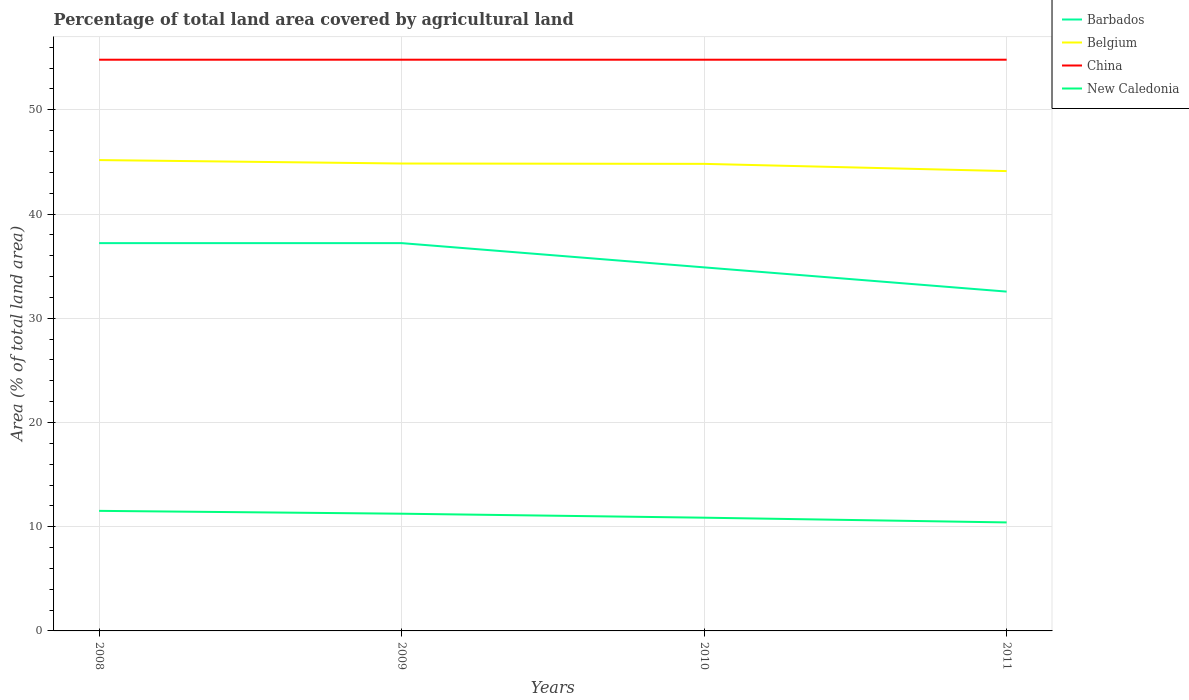How many different coloured lines are there?
Your answer should be very brief. 4. Does the line corresponding to Barbados intersect with the line corresponding to New Caledonia?
Keep it short and to the point. No. Across all years, what is the maximum percentage of agricultural land in Barbados?
Offer a terse response. 32.56. In which year was the percentage of agricultural land in Belgium maximum?
Provide a short and direct response. 2011. What is the total percentage of agricultural land in Belgium in the graph?
Your response must be concise. 0.69. What is the difference between the highest and the second highest percentage of agricultural land in New Caledonia?
Keep it short and to the point. 1.11. What is the difference between the highest and the lowest percentage of agricultural land in Barbados?
Offer a very short reply. 2. Does the graph contain any zero values?
Give a very brief answer. No. Where does the legend appear in the graph?
Provide a succinct answer. Top right. How many legend labels are there?
Your answer should be compact. 4. What is the title of the graph?
Provide a short and direct response. Percentage of total land area covered by agricultural land. Does "World" appear as one of the legend labels in the graph?
Your response must be concise. No. What is the label or title of the Y-axis?
Offer a terse response. Area (% of total land area). What is the Area (% of total land area) in Barbados in 2008?
Keep it short and to the point. 37.21. What is the Area (% of total land area) in Belgium in 2008?
Your response must be concise. 45.18. What is the Area (% of total land area) of China in 2008?
Your answer should be compact. 54.81. What is the Area (% of total land area) in New Caledonia in 2008?
Keep it short and to the point. 11.52. What is the Area (% of total land area) in Barbados in 2009?
Keep it short and to the point. 37.21. What is the Area (% of total land area) of Belgium in 2009?
Your answer should be compact. 44.85. What is the Area (% of total land area) in China in 2009?
Ensure brevity in your answer.  54.81. What is the Area (% of total land area) in New Caledonia in 2009?
Your response must be concise. 11.25. What is the Area (% of total land area) in Barbados in 2010?
Keep it short and to the point. 34.88. What is the Area (% of total land area) in Belgium in 2010?
Make the answer very short. 44.82. What is the Area (% of total land area) in China in 2010?
Offer a very short reply. 54.81. What is the Area (% of total land area) of New Caledonia in 2010?
Make the answer very short. 10.86. What is the Area (% of total land area) of Barbados in 2011?
Ensure brevity in your answer.  32.56. What is the Area (% of total land area) of Belgium in 2011?
Provide a short and direct response. 44.12. What is the Area (% of total land area) in China in 2011?
Offer a terse response. 54.81. What is the Area (% of total land area) in New Caledonia in 2011?
Offer a terse response. 10.41. Across all years, what is the maximum Area (% of total land area) in Barbados?
Provide a short and direct response. 37.21. Across all years, what is the maximum Area (% of total land area) in Belgium?
Give a very brief answer. 45.18. Across all years, what is the maximum Area (% of total land area) in China?
Ensure brevity in your answer.  54.81. Across all years, what is the maximum Area (% of total land area) of New Caledonia?
Give a very brief answer. 11.52. Across all years, what is the minimum Area (% of total land area) of Barbados?
Offer a terse response. 32.56. Across all years, what is the minimum Area (% of total land area) of Belgium?
Your answer should be compact. 44.12. Across all years, what is the minimum Area (% of total land area) in China?
Provide a short and direct response. 54.81. Across all years, what is the minimum Area (% of total land area) of New Caledonia?
Give a very brief answer. 10.41. What is the total Area (% of total land area) of Barbados in the graph?
Your response must be concise. 141.86. What is the total Area (% of total land area) in Belgium in the graph?
Offer a very short reply. 178.96. What is the total Area (% of total land area) of China in the graph?
Keep it short and to the point. 219.23. What is the total Area (% of total land area) in New Caledonia in the graph?
Ensure brevity in your answer.  44.04. What is the difference between the Area (% of total land area) of Barbados in 2008 and that in 2009?
Your answer should be very brief. 0. What is the difference between the Area (% of total land area) in Belgium in 2008 and that in 2009?
Provide a short and direct response. 0.33. What is the difference between the Area (% of total land area) of China in 2008 and that in 2009?
Your response must be concise. -0. What is the difference between the Area (% of total land area) in New Caledonia in 2008 and that in 2009?
Provide a short and direct response. 0.27. What is the difference between the Area (% of total land area) in Barbados in 2008 and that in 2010?
Make the answer very short. 2.33. What is the difference between the Area (% of total land area) of Belgium in 2008 and that in 2010?
Your response must be concise. 0.36. What is the difference between the Area (% of total land area) of China in 2008 and that in 2010?
Your answer should be very brief. -0. What is the difference between the Area (% of total land area) of New Caledonia in 2008 and that in 2010?
Offer a very short reply. 0.66. What is the difference between the Area (% of total land area) in Barbados in 2008 and that in 2011?
Provide a succinct answer. 4.65. What is the difference between the Area (% of total land area) in Belgium in 2008 and that in 2011?
Make the answer very short. 1.06. What is the difference between the Area (% of total land area) in China in 2008 and that in 2011?
Offer a very short reply. -0. What is the difference between the Area (% of total land area) in New Caledonia in 2008 and that in 2011?
Offer a terse response. 1.11. What is the difference between the Area (% of total land area) in Barbados in 2009 and that in 2010?
Provide a succinct answer. 2.33. What is the difference between the Area (% of total land area) in Belgium in 2009 and that in 2010?
Give a very brief answer. 0.03. What is the difference between the Area (% of total land area) of China in 2009 and that in 2010?
Keep it short and to the point. 0. What is the difference between the Area (% of total land area) in New Caledonia in 2009 and that in 2010?
Offer a very short reply. 0.38. What is the difference between the Area (% of total land area) of Barbados in 2009 and that in 2011?
Your answer should be compact. 4.65. What is the difference between the Area (% of total land area) in Belgium in 2009 and that in 2011?
Your response must be concise. 0.73. What is the difference between the Area (% of total land area) of New Caledonia in 2009 and that in 2011?
Give a very brief answer. 0.84. What is the difference between the Area (% of total land area) in Barbados in 2010 and that in 2011?
Provide a short and direct response. 2.33. What is the difference between the Area (% of total land area) in Belgium in 2010 and that in 2011?
Make the answer very short. 0.69. What is the difference between the Area (% of total land area) in China in 2010 and that in 2011?
Provide a short and direct response. -0. What is the difference between the Area (% of total land area) of New Caledonia in 2010 and that in 2011?
Make the answer very short. 0.45. What is the difference between the Area (% of total land area) in Barbados in 2008 and the Area (% of total land area) in Belgium in 2009?
Your answer should be compact. -7.64. What is the difference between the Area (% of total land area) of Barbados in 2008 and the Area (% of total land area) of China in 2009?
Provide a succinct answer. -17.6. What is the difference between the Area (% of total land area) in Barbados in 2008 and the Area (% of total land area) in New Caledonia in 2009?
Your response must be concise. 25.96. What is the difference between the Area (% of total land area) of Belgium in 2008 and the Area (% of total land area) of China in 2009?
Offer a very short reply. -9.63. What is the difference between the Area (% of total land area) in Belgium in 2008 and the Area (% of total land area) in New Caledonia in 2009?
Keep it short and to the point. 33.93. What is the difference between the Area (% of total land area) of China in 2008 and the Area (% of total land area) of New Caledonia in 2009?
Your response must be concise. 43.56. What is the difference between the Area (% of total land area) of Barbados in 2008 and the Area (% of total land area) of Belgium in 2010?
Provide a short and direct response. -7.61. What is the difference between the Area (% of total land area) of Barbados in 2008 and the Area (% of total land area) of China in 2010?
Your response must be concise. -17.6. What is the difference between the Area (% of total land area) of Barbados in 2008 and the Area (% of total land area) of New Caledonia in 2010?
Your answer should be compact. 26.34. What is the difference between the Area (% of total land area) of Belgium in 2008 and the Area (% of total land area) of China in 2010?
Offer a very short reply. -9.63. What is the difference between the Area (% of total land area) of Belgium in 2008 and the Area (% of total land area) of New Caledonia in 2010?
Your answer should be very brief. 34.31. What is the difference between the Area (% of total land area) of China in 2008 and the Area (% of total land area) of New Caledonia in 2010?
Provide a succinct answer. 43.94. What is the difference between the Area (% of total land area) of Barbados in 2008 and the Area (% of total land area) of Belgium in 2011?
Your response must be concise. -6.91. What is the difference between the Area (% of total land area) of Barbados in 2008 and the Area (% of total land area) of China in 2011?
Your answer should be compact. -17.6. What is the difference between the Area (% of total land area) in Barbados in 2008 and the Area (% of total land area) in New Caledonia in 2011?
Ensure brevity in your answer.  26.8. What is the difference between the Area (% of total land area) in Belgium in 2008 and the Area (% of total land area) in China in 2011?
Provide a short and direct response. -9.63. What is the difference between the Area (% of total land area) of Belgium in 2008 and the Area (% of total land area) of New Caledonia in 2011?
Your response must be concise. 34.77. What is the difference between the Area (% of total land area) of China in 2008 and the Area (% of total land area) of New Caledonia in 2011?
Keep it short and to the point. 44.4. What is the difference between the Area (% of total land area) in Barbados in 2009 and the Area (% of total land area) in Belgium in 2010?
Make the answer very short. -7.61. What is the difference between the Area (% of total land area) in Barbados in 2009 and the Area (% of total land area) in China in 2010?
Make the answer very short. -17.6. What is the difference between the Area (% of total land area) of Barbados in 2009 and the Area (% of total land area) of New Caledonia in 2010?
Give a very brief answer. 26.34. What is the difference between the Area (% of total land area) of Belgium in 2009 and the Area (% of total land area) of China in 2010?
Give a very brief answer. -9.96. What is the difference between the Area (% of total land area) in Belgium in 2009 and the Area (% of total land area) in New Caledonia in 2010?
Your response must be concise. 33.98. What is the difference between the Area (% of total land area) of China in 2009 and the Area (% of total land area) of New Caledonia in 2010?
Ensure brevity in your answer.  43.94. What is the difference between the Area (% of total land area) of Barbados in 2009 and the Area (% of total land area) of Belgium in 2011?
Your response must be concise. -6.91. What is the difference between the Area (% of total land area) in Barbados in 2009 and the Area (% of total land area) in China in 2011?
Keep it short and to the point. -17.6. What is the difference between the Area (% of total land area) of Barbados in 2009 and the Area (% of total land area) of New Caledonia in 2011?
Keep it short and to the point. 26.8. What is the difference between the Area (% of total land area) of Belgium in 2009 and the Area (% of total land area) of China in 2011?
Offer a terse response. -9.96. What is the difference between the Area (% of total land area) in Belgium in 2009 and the Area (% of total land area) in New Caledonia in 2011?
Your response must be concise. 34.44. What is the difference between the Area (% of total land area) in China in 2009 and the Area (% of total land area) in New Caledonia in 2011?
Give a very brief answer. 44.4. What is the difference between the Area (% of total land area) of Barbados in 2010 and the Area (% of total land area) of Belgium in 2011?
Offer a terse response. -9.24. What is the difference between the Area (% of total land area) of Barbados in 2010 and the Area (% of total land area) of China in 2011?
Your answer should be compact. -19.92. What is the difference between the Area (% of total land area) in Barbados in 2010 and the Area (% of total land area) in New Caledonia in 2011?
Offer a very short reply. 24.47. What is the difference between the Area (% of total land area) of Belgium in 2010 and the Area (% of total land area) of China in 2011?
Offer a very short reply. -9.99. What is the difference between the Area (% of total land area) of Belgium in 2010 and the Area (% of total land area) of New Caledonia in 2011?
Offer a terse response. 34.4. What is the difference between the Area (% of total land area) in China in 2010 and the Area (% of total land area) in New Caledonia in 2011?
Your response must be concise. 44.4. What is the average Area (% of total land area) of Barbados per year?
Offer a very short reply. 35.47. What is the average Area (% of total land area) of Belgium per year?
Offer a very short reply. 44.74. What is the average Area (% of total land area) in China per year?
Give a very brief answer. 54.81. What is the average Area (% of total land area) in New Caledonia per year?
Your answer should be compact. 11.01. In the year 2008, what is the difference between the Area (% of total land area) in Barbados and Area (% of total land area) in Belgium?
Give a very brief answer. -7.97. In the year 2008, what is the difference between the Area (% of total land area) in Barbados and Area (% of total land area) in China?
Give a very brief answer. -17.6. In the year 2008, what is the difference between the Area (% of total land area) in Barbados and Area (% of total land area) in New Caledonia?
Keep it short and to the point. 25.69. In the year 2008, what is the difference between the Area (% of total land area) of Belgium and Area (% of total land area) of China?
Keep it short and to the point. -9.63. In the year 2008, what is the difference between the Area (% of total land area) of Belgium and Area (% of total land area) of New Caledonia?
Give a very brief answer. 33.66. In the year 2008, what is the difference between the Area (% of total land area) of China and Area (% of total land area) of New Caledonia?
Give a very brief answer. 43.29. In the year 2009, what is the difference between the Area (% of total land area) in Barbados and Area (% of total land area) in Belgium?
Ensure brevity in your answer.  -7.64. In the year 2009, what is the difference between the Area (% of total land area) of Barbados and Area (% of total land area) of China?
Ensure brevity in your answer.  -17.6. In the year 2009, what is the difference between the Area (% of total land area) in Barbados and Area (% of total land area) in New Caledonia?
Provide a succinct answer. 25.96. In the year 2009, what is the difference between the Area (% of total land area) in Belgium and Area (% of total land area) in China?
Your answer should be compact. -9.96. In the year 2009, what is the difference between the Area (% of total land area) in Belgium and Area (% of total land area) in New Caledonia?
Keep it short and to the point. 33.6. In the year 2009, what is the difference between the Area (% of total land area) of China and Area (% of total land area) of New Caledonia?
Your answer should be compact. 43.56. In the year 2010, what is the difference between the Area (% of total land area) in Barbados and Area (% of total land area) in Belgium?
Your response must be concise. -9.93. In the year 2010, what is the difference between the Area (% of total land area) in Barbados and Area (% of total land area) in China?
Offer a very short reply. -19.92. In the year 2010, what is the difference between the Area (% of total land area) in Barbados and Area (% of total land area) in New Caledonia?
Provide a short and direct response. 24.02. In the year 2010, what is the difference between the Area (% of total land area) of Belgium and Area (% of total land area) of China?
Ensure brevity in your answer.  -9.99. In the year 2010, what is the difference between the Area (% of total land area) of Belgium and Area (% of total land area) of New Caledonia?
Give a very brief answer. 33.95. In the year 2010, what is the difference between the Area (% of total land area) of China and Area (% of total land area) of New Caledonia?
Keep it short and to the point. 43.94. In the year 2011, what is the difference between the Area (% of total land area) of Barbados and Area (% of total land area) of Belgium?
Your answer should be very brief. -11.56. In the year 2011, what is the difference between the Area (% of total land area) of Barbados and Area (% of total land area) of China?
Make the answer very short. -22.25. In the year 2011, what is the difference between the Area (% of total land area) in Barbados and Area (% of total land area) in New Caledonia?
Your answer should be very brief. 22.15. In the year 2011, what is the difference between the Area (% of total land area) in Belgium and Area (% of total land area) in China?
Offer a terse response. -10.69. In the year 2011, what is the difference between the Area (% of total land area) of Belgium and Area (% of total land area) of New Caledonia?
Provide a succinct answer. 33.71. In the year 2011, what is the difference between the Area (% of total land area) in China and Area (% of total land area) in New Caledonia?
Your answer should be compact. 44.4. What is the ratio of the Area (% of total land area) of Belgium in 2008 to that in 2009?
Provide a succinct answer. 1.01. What is the ratio of the Area (% of total land area) of New Caledonia in 2008 to that in 2009?
Your answer should be very brief. 1.02. What is the ratio of the Area (% of total land area) in Barbados in 2008 to that in 2010?
Make the answer very short. 1.07. What is the ratio of the Area (% of total land area) of China in 2008 to that in 2010?
Your answer should be compact. 1. What is the ratio of the Area (% of total land area) of New Caledonia in 2008 to that in 2010?
Offer a very short reply. 1.06. What is the ratio of the Area (% of total land area) in Barbados in 2008 to that in 2011?
Your answer should be compact. 1.14. What is the ratio of the Area (% of total land area) of New Caledonia in 2008 to that in 2011?
Provide a succinct answer. 1.11. What is the ratio of the Area (% of total land area) in Barbados in 2009 to that in 2010?
Give a very brief answer. 1.07. What is the ratio of the Area (% of total land area) in New Caledonia in 2009 to that in 2010?
Make the answer very short. 1.04. What is the ratio of the Area (% of total land area) of Belgium in 2009 to that in 2011?
Offer a very short reply. 1.02. What is the ratio of the Area (% of total land area) of New Caledonia in 2009 to that in 2011?
Make the answer very short. 1.08. What is the ratio of the Area (% of total land area) in Barbados in 2010 to that in 2011?
Your response must be concise. 1.07. What is the ratio of the Area (% of total land area) of Belgium in 2010 to that in 2011?
Make the answer very short. 1.02. What is the ratio of the Area (% of total land area) in China in 2010 to that in 2011?
Offer a very short reply. 1. What is the ratio of the Area (% of total land area) of New Caledonia in 2010 to that in 2011?
Keep it short and to the point. 1.04. What is the difference between the highest and the second highest Area (% of total land area) in Barbados?
Your response must be concise. 0. What is the difference between the highest and the second highest Area (% of total land area) in Belgium?
Provide a succinct answer. 0.33. What is the difference between the highest and the second highest Area (% of total land area) in China?
Your response must be concise. 0. What is the difference between the highest and the second highest Area (% of total land area) in New Caledonia?
Offer a very short reply. 0.27. What is the difference between the highest and the lowest Area (% of total land area) of Barbados?
Provide a short and direct response. 4.65. What is the difference between the highest and the lowest Area (% of total land area) in Belgium?
Give a very brief answer. 1.06. What is the difference between the highest and the lowest Area (% of total land area) in China?
Your answer should be very brief. 0. What is the difference between the highest and the lowest Area (% of total land area) of New Caledonia?
Offer a terse response. 1.11. 